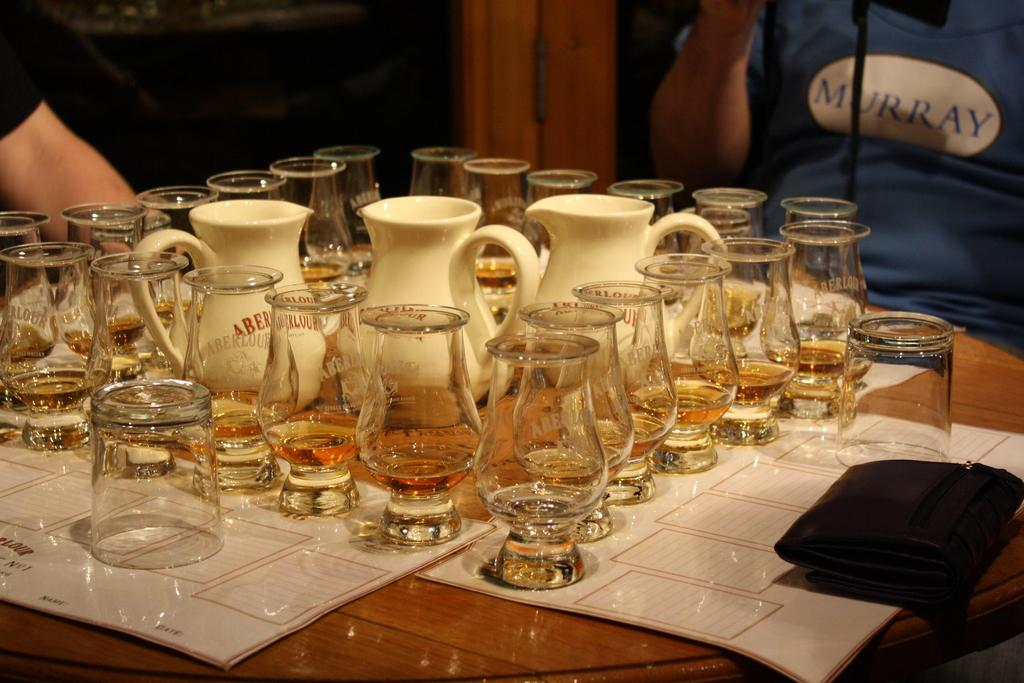What objects are on the table in the image? There are jars and glasses on the table in the image. What else can be seen in the image besides the table? There are papers and a wallet in the image. Can you describe the person in the image? A person is sitting on the backside of the image. How many nerves are visible in the image? There are no nerves visible in the image. What type of books can be seen on the table in the image? There are no books present in the image. 